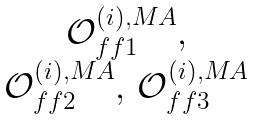<formula> <loc_0><loc_0><loc_500><loc_500>\begin{matrix} \mathcal { O } ^ { ( i ) , M A } _ { f f 1 } , \\ \mathcal { O } ^ { ( i ) , M A } _ { f f 2 } , \, \mathcal { O } ^ { ( i ) , M A } _ { f f 3 } \end{matrix}</formula> 